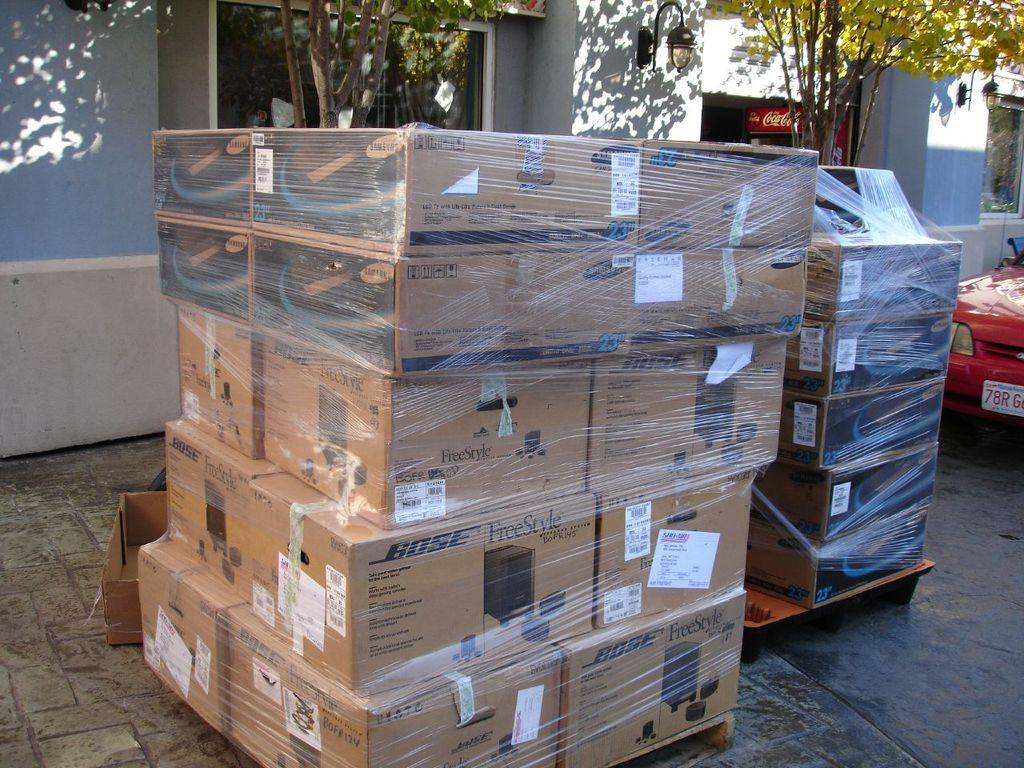<image>
Summarize the visual content of the image. stacks of boxes all wrapped up, labelled BOSE on the top left corners 